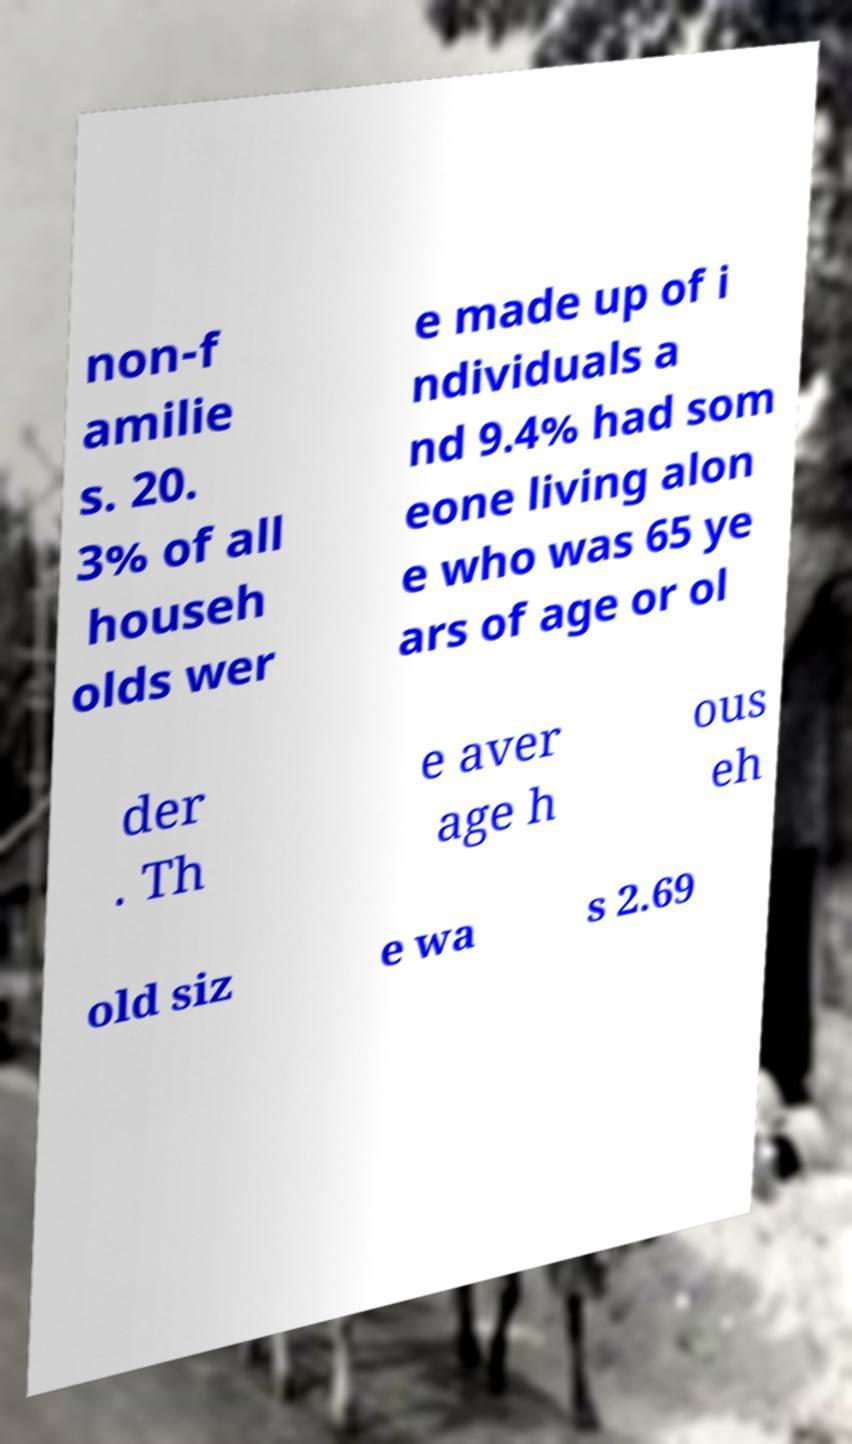Please read and relay the text visible in this image. What does it say? non-f amilie s. 20. 3% of all househ olds wer e made up of i ndividuals a nd 9.4% had som eone living alon e who was 65 ye ars of age or ol der . Th e aver age h ous eh old siz e wa s 2.69 